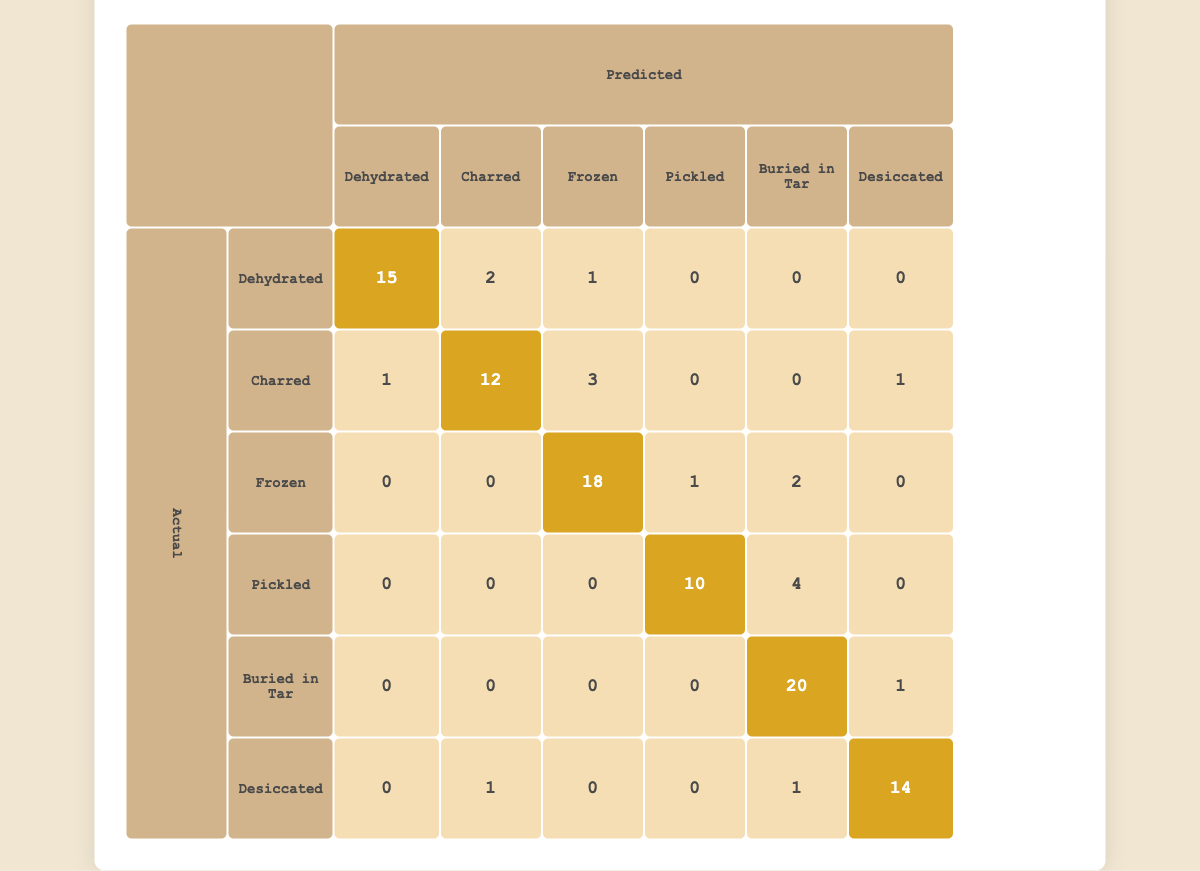What is the total number of correctly predicted dehydrated remains? The correctly predicted dehydrated remains are found in the first row of the matrix, where the actual and predicted values are both "Dehydrated." The value in this cell is 15.
Answer: 15 How many charred remains were misclassified as pickled? To find this, we will look at the second row under the "Pickled" column. The value there represents the charred remains misclassified as pickled, which is 0.
Answer: 0 What percentage of frozen remains were correctly classified? The total number of actual frozen remains is the sum of values in the frozen column: 18 (correct) + 1 + 2 = 21. The correctly classified frozen remains are 18. The percentage is then (18/21) * 100, which equals approximately 85.71%.
Answer: 85.71 Are there more instances of desiccated remains misclassified than correctly classified? The correctly classified desiccated remains are found in the "Desiccated" row and column, which is 14. The misclassifications (adding across the row for this category) are 0 (Dehydrated) + 1 (Charred) + 0 (Frozen) + 0 (Pickled) + 1 (Buried in Tar) = 2. Since 2 is less than 14, the answer is no.
Answer: No What is the total number of predictions made for pickled remains? To find the total predictions for pickled, we sum all values in the "Pickled" column: 0 (Dehydrated) + 0 (Charred) + 0 (Frozen) + 10 (Pickled) + 0 (Buried in Tar) + 0 (Desiccated) + 4 = 14.
Answer: 14 Which preservation method had the highest number of misclassifications? To identify the preservation method with the highest misclassifications, we look for the highest sums of values in each row (excluding the diagonal). The maximum occurs in the "Buried in Tar" row, totaling 1 (Charred) + 0 + 0 + 0 + 1 (Desiccated) = 2. No other method has more misclassifications.
Answer: Buried in Tar How many total predictions were made for all preservation methods? This can be calculated by summing up all values in the confusion matrix. The total is 15 + 2 + 1 + 0 + 0 + 0 + 1 + 12 + 3 + 0 + 0 + 1 + 0 + 0 + 18 + 1 + 2 + 0 + 0 + 10 + 4 + 0 + 0 + 20 + 1 + 0 + 0 + 1 + 14 = 92.
Answer: 92 What is the ratio of correctly classified charred remains to the total predictions for charred? The correctly classified charred remains are represented by the value 12 in the "Charred" row and column. The total predictions for charred are 1 + 12 + 3 + 0 + 0 + 1 = 17. The ratio is then 12:17.
Answer: 12:17 What is the difference in the number of correctly classified frozen and pickled remains? The number of correctly classified frozen remains is 18, and for pickled remains, it is 10. The difference is 18 - 10 = 8.
Answer: 8 